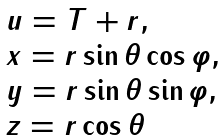Convert formula to latex. <formula><loc_0><loc_0><loc_500><loc_500>\begin{array} { l } u = T + r , \\ x = r \sin \theta \cos \varphi , \\ y = r \sin \theta \sin \varphi , \\ z = r \cos \theta \end{array}</formula> 